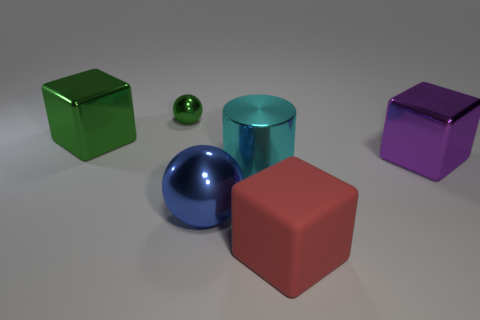Subtract all metallic cubes. How many cubes are left? 1 Add 1 red rubber blocks. How many objects exist? 7 Subtract all purple blocks. How many blocks are left? 2 Subtract all cylinders. How many objects are left? 5 Subtract all big cyan metallic cylinders. Subtract all green things. How many objects are left? 3 Add 5 green metal objects. How many green metal objects are left? 7 Add 5 large blue things. How many large blue things exist? 6 Subtract 0 brown cylinders. How many objects are left? 6 Subtract all blue cylinders. Subtract all red cubes. How many cylinders are left? 1 